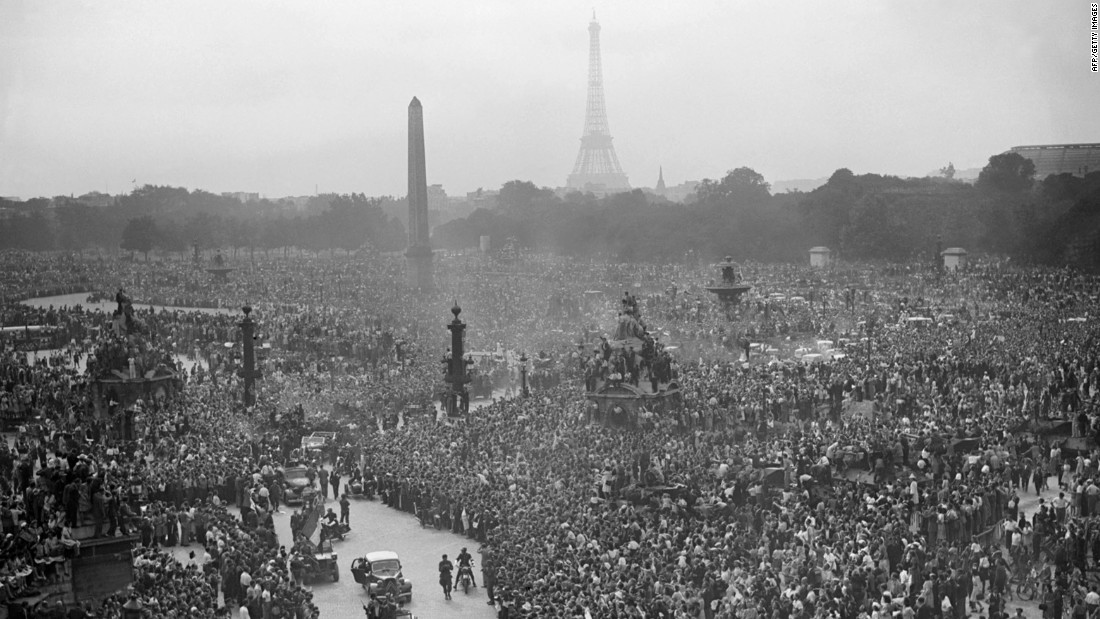Can you describe the atmosphere and emotions that might be felt by the crowd in this photograph? The atmosphere in this image seems electrifying and charged with a mix of jubilation, relief, and collective pride. The large, dense crowd suggests a shared, communal rejoicing, likely because of a significant positive event. You can almost hear the cheers and feel the unity that such a significant assembly would foster. Such a large gathering, with people perched on statues and lampposts, indicates the eagerness and excitement of the crowd, reflecting a moment of communal triumph and celebration. 